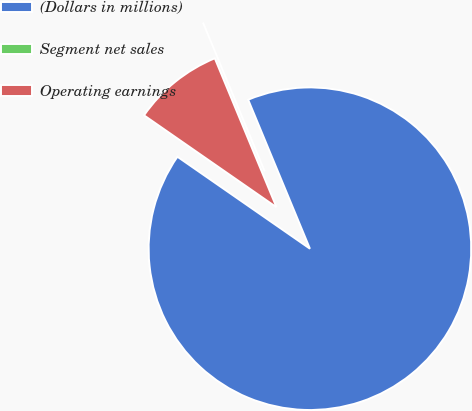<chart> <loc_0><loc_0><loc_500><loc_500><pie_chart><fcel>(Dollars in millions)<fcel>Segment net sales<fcel>Operating earnings<nl><fcel>90.91%<fcel>0.0%<fcel>9.09%<nl></chart> 